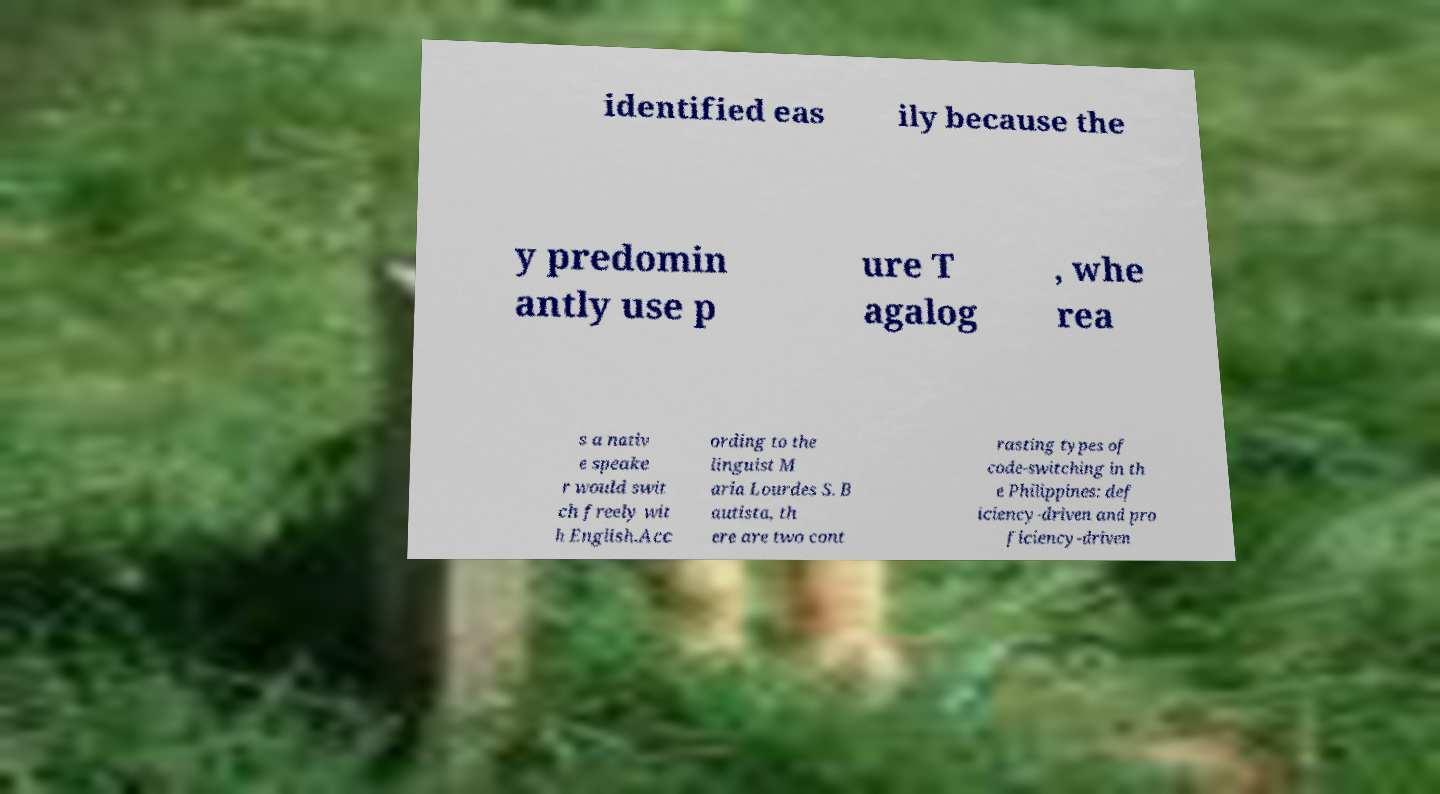Could you assist in decoding the text presented in this image and type it out clearly? identified eas ily because the y predomin antly use p ure T agalog , whe rea s a nativ e speake r would swit ch freely wit h English.Acc ording to the linguist M aria Lourdes S. B autista, th ere are two cont rasting types of code-switching in th e Philippines: def iciency-driven and pro ficiency-driven 